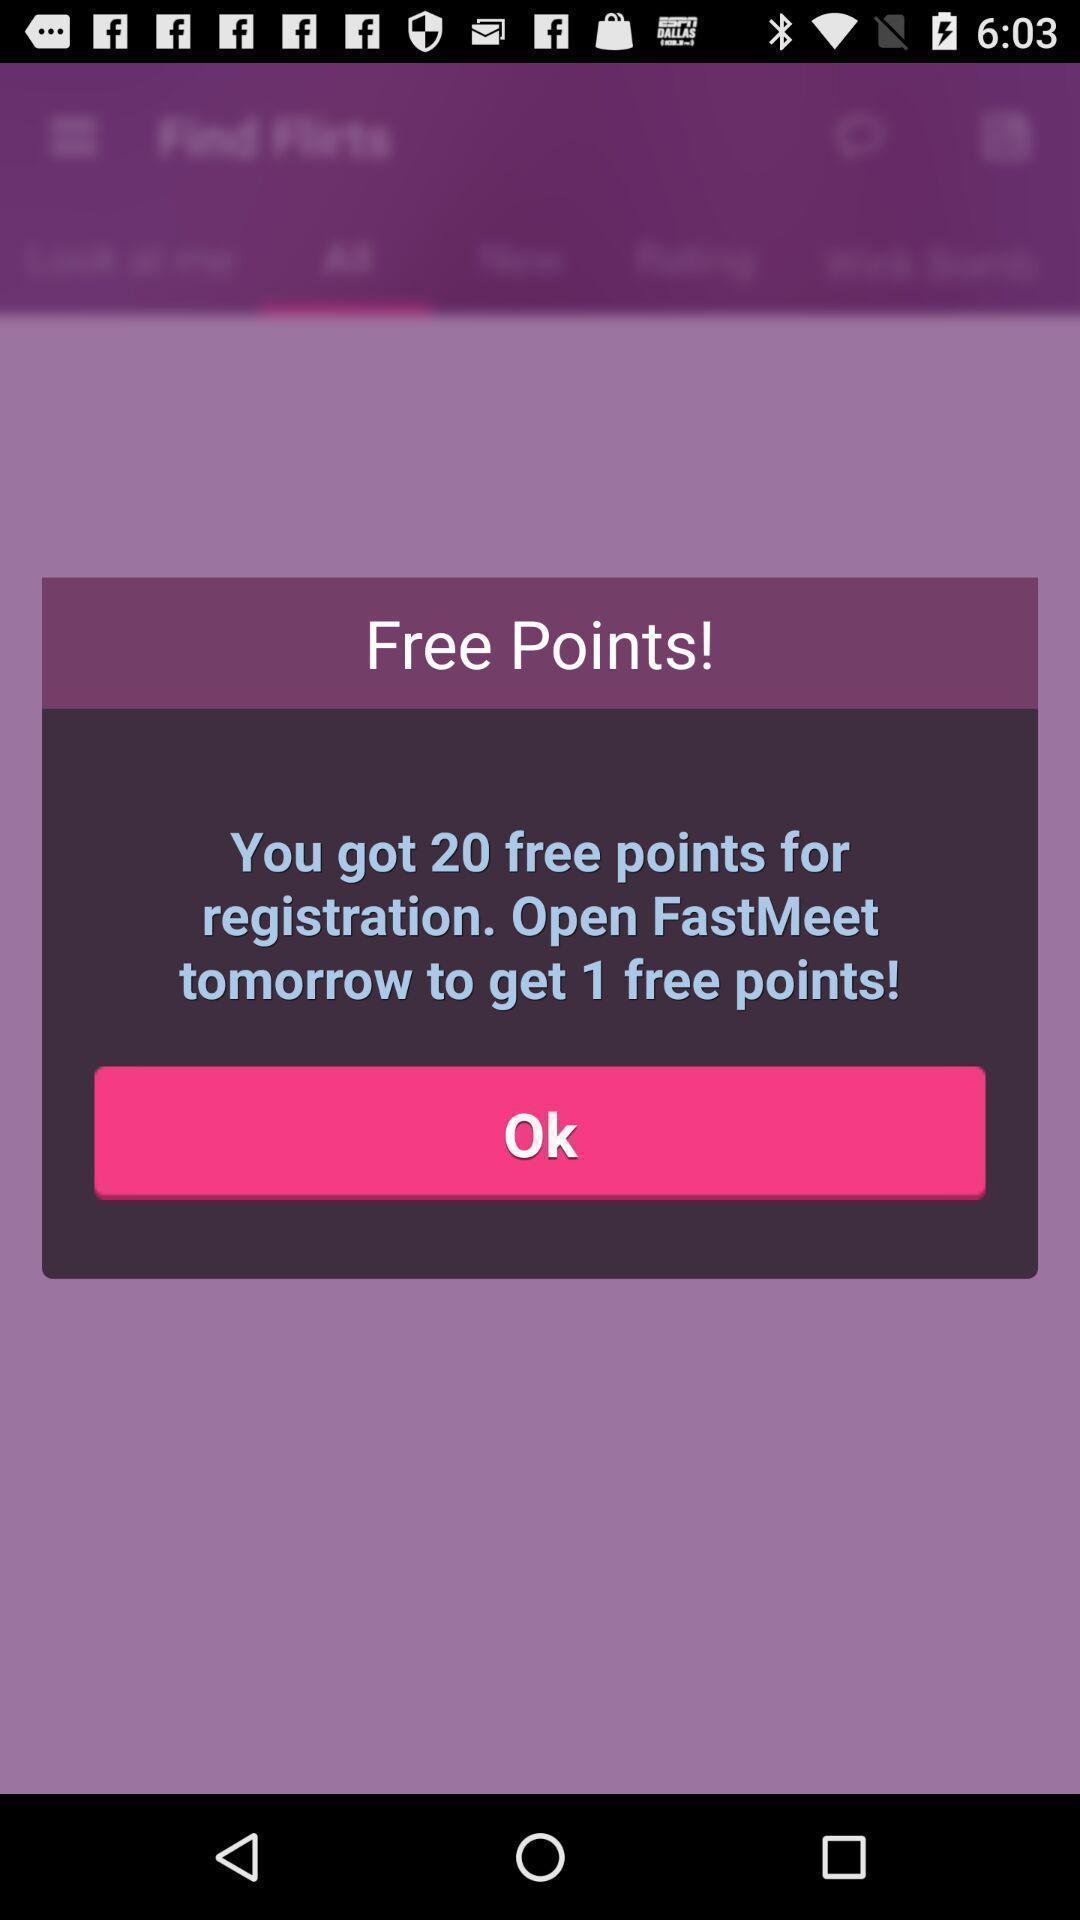Summarize the main components in this picture. Pop-up showing a reward message. 